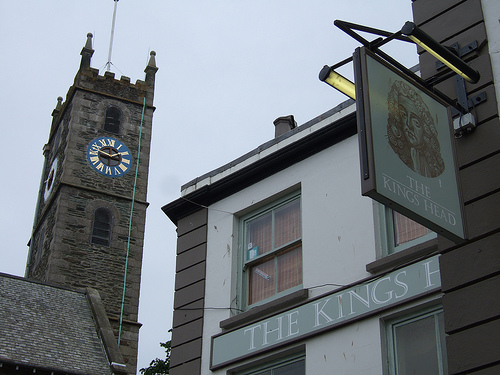What activities or businesses can you infer are present around this area based on the image details? Based on the signage and overall appearance, there appears to be a pub named 'The King's Head' suggesting social and dining activities. The presence of a bus and public road also hints at a well-trafficked area, likely with more shops and services nearby. 